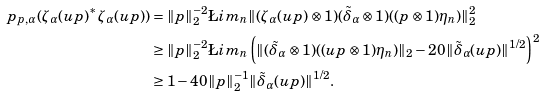Convert formula to latex. <formula><loc_0><loc_0><loc_500><loc_500>\ p _ { p , \alpha } ( \zeta _ { \alpha } ( u p ) ^ { * } \zeta _ { \alpha } ( u p ) ) & = \| p \| _ { 2 } ^ { - 2 } \L i m _ { n } \| ( \zeta _ { \alpha } ( u p ) \otimes 1 ) ( \tilde { \delta } _ { \alpha } \otimes 1 ) ( ( p \otimes 1 ) \eta _ { n } ) \| _ { 2 } ^ { 2 } \\ & \geq \| p \| _ { 2 } ^ { - 2 } \L i m _ { n } \left ( \| ( \tilde { \delta } _ { \alpha } \otimes 1 ) ( ( u p \otimes 1 ) \eta _ { n } ) \| _ { 2 } - 2 0 \| \tilde { \delta } _ { \alpha } ( u p ) \| ^ { 1 / 2 } \right ) ^ { 2 } \\ & \geq 1 - 4 0 \| p \| _ { 2 } ^ { - 1 } \| \tilde { \delta } _ { \alpha } ( u p ) \| ^ { 1 / 2 } .</formula> 